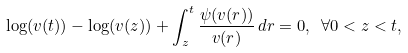Convert formula to latex. <formula><loc_0><loc_0><loc_500><loc_500>\log ( v ( t ) ) - \log ( v ( z ) ) + \int _ { z } ^ { t } \frac { \psi ( v ( r ) ) } { v ( r ) } \, d r = 0 , \ \forall 0 < z < t ,</formula> 